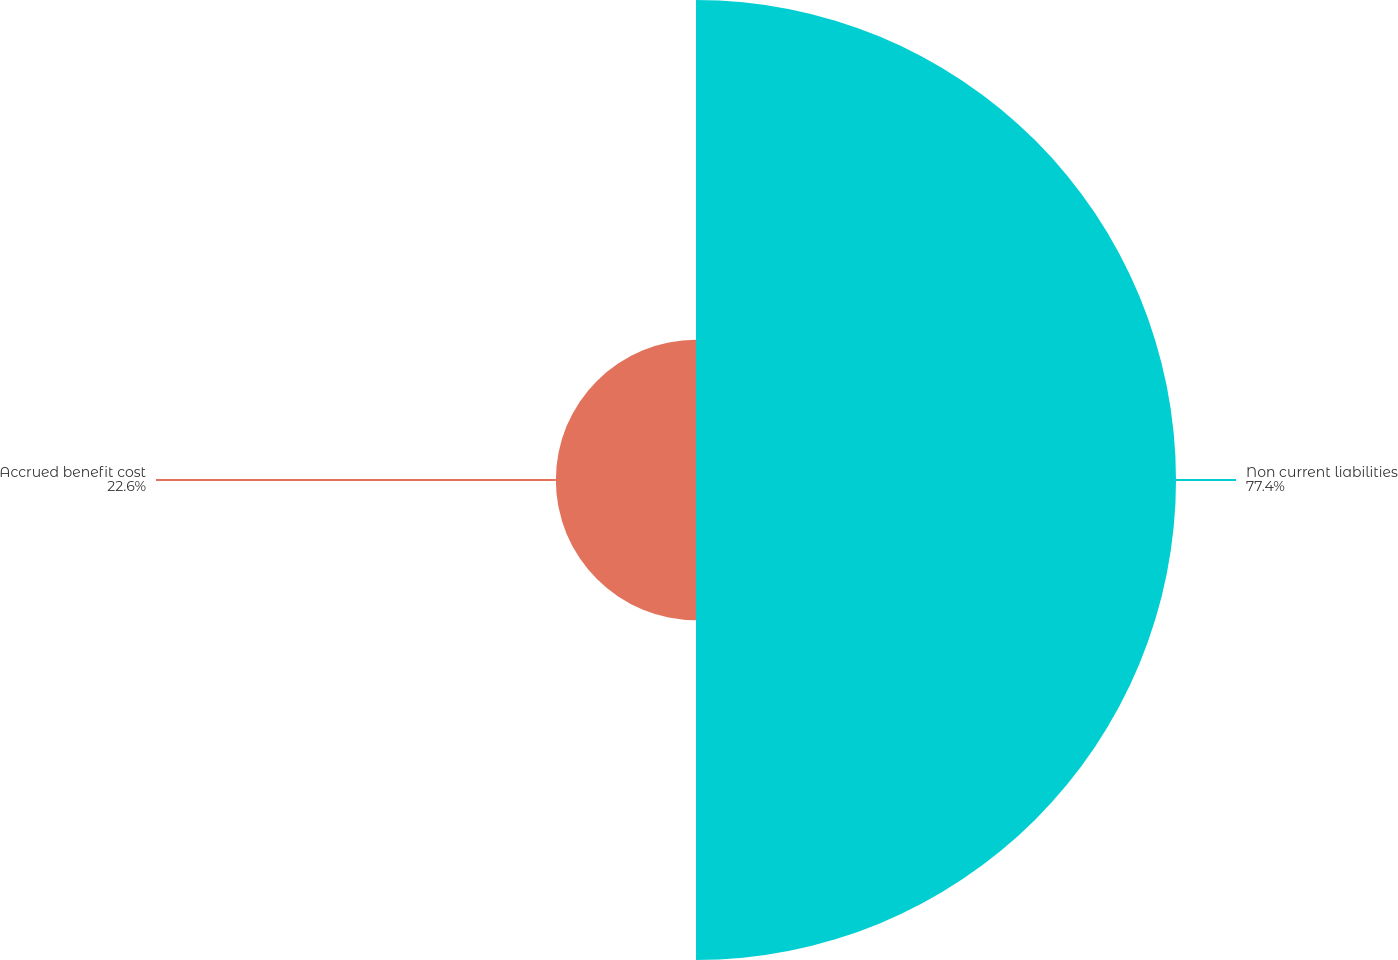Convert chart to OTSL. <chart><loc_0><loc_0><loc_500><loc_500><pie_chart><fcel>Non current liabilities<fcel>Accrued benefit cost<nl><fcel>77.4%<fcel>22.6%<nl></chart> 